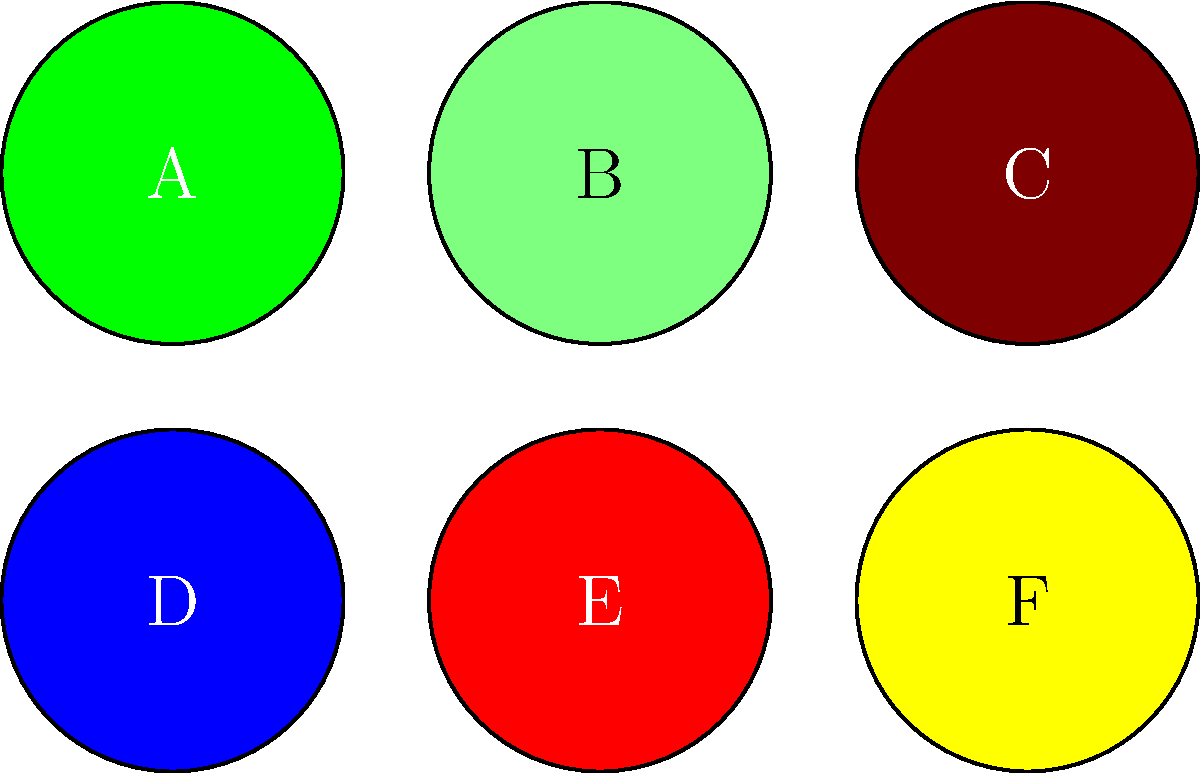Which symbol represents the USDA Organic certification commonly found on organic baby food products? To identify the USDA Organic certification symbol:

1. Recall that the USDA Organic seal is circular in shape.
2. The official color of the USDA Organic seal is white and green.
3. Examine the given symbols:
   A: Green circle
   B: Light green circle
   C: Brown circle
   D: Blue circle
   E: Red circle
   F: Yellow circle
4. The symbol that most closely matches the USDA Organic seal is A, the green circle.
5. In reality, the USDA Organic seal would have "USDA ORGANIC" text inside the circle, but for this simplified representation, the green circle (A) is the best match.

As a new parent looking for organic food options for your baby, it's crucial to recognize this symbol on product packaging to ensure you're choosing certified organic products.
Answer: A 